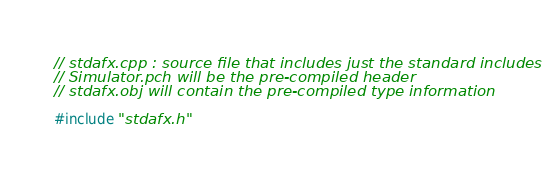Convert code to text. <code><loc_0><loc_0><loc_500><loc_500><_C++_>// stdafx.cpp : source file that includes just the standard includes
// Simulator.pch will be the pre-compiled header
// stdafx.obj will contain the pre-compiled type information

#include "stdafx.h"


</code> 